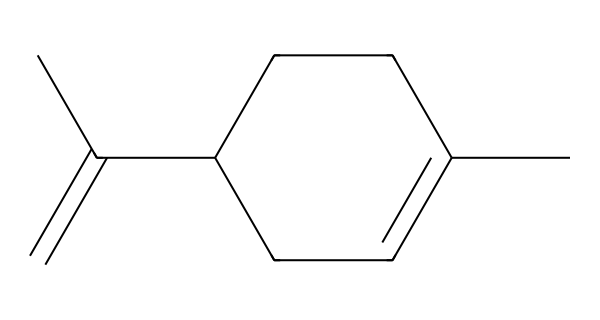What is the chemical name represented by this SMILES? The SMILES code CC1=CCC(CC1)C(=C)C depicts a structure well known in organic chemistry; it corresponds to limonene, a cyclic monoterpene with a citrus aroma.
Answer: limonene How many carbon atoms are in limonene? By counting the carbon atoms in the SMILES representation, there are a total of 10 carbon (C) atoms present in the structure.
Answer: 10 What type of chemical compound is limonene categorized as? Limonene falls under the category of terpenes, specifically monoterpenes, which are compounds made up of two isoprene units, showcasing the structure of terpenes.
Answer: terpene What is the degree of unsaturation in limonene? To find the degree of unsaturation, we count the number of rings and double bonds; there is one ring and two double bonds, which results in a degree of unsaturation of 3.
Answer: 3 Does limonene contain any functional groups? Limonene primarily contains a double bond characteristic of alkenes, which is the primary functional group identified in its structure.
Answer: alkene What is the molecular formula for limonene? The molecular formula can be derived from counting the atoms in the SMILES: C10H16, reflecting the total number of carbon and hydrogen atoms in the structure.
Answer: C10H16 Which part of limonene contributes to its citrus scent? The specific structure of limonene including its cyclic and unsaturated nature, particularly the arrangement and presence of its double bonds, contributes to its distinct citrus aroma.
Answer: cyclic structure 